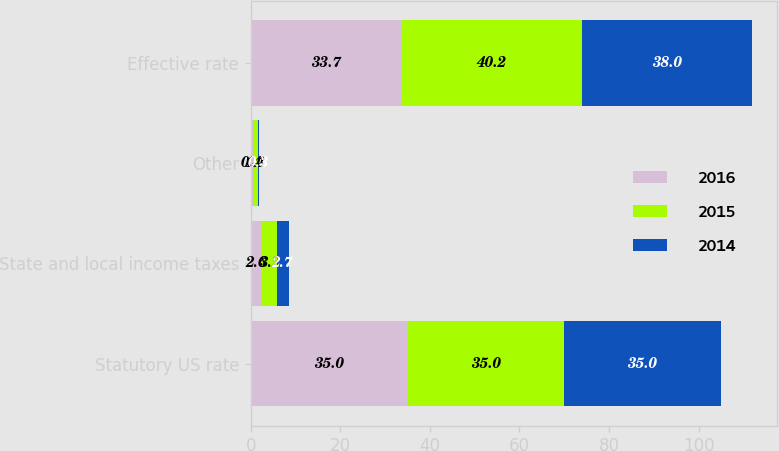Convert chart to OTSL. <chart><loc_0><loc_0><loc_500><loc_500><stacked_bar_chart><ecel><fcel>Statutory US rate<fcel>State and local income taxes<fcel>Other<fcel>Effective rate<nl><fcel>2016<fcel>35<fcel>2.6<fcel>0.4<fcel>33.7<nl><fcel>2015<fcel>35<fcel>3.2<fcel>1.1<fcel>40.2<nl><fcel>2014<fcel>35<fcel>2.7<fcel>0.3<fcel>38<nl></chart> 